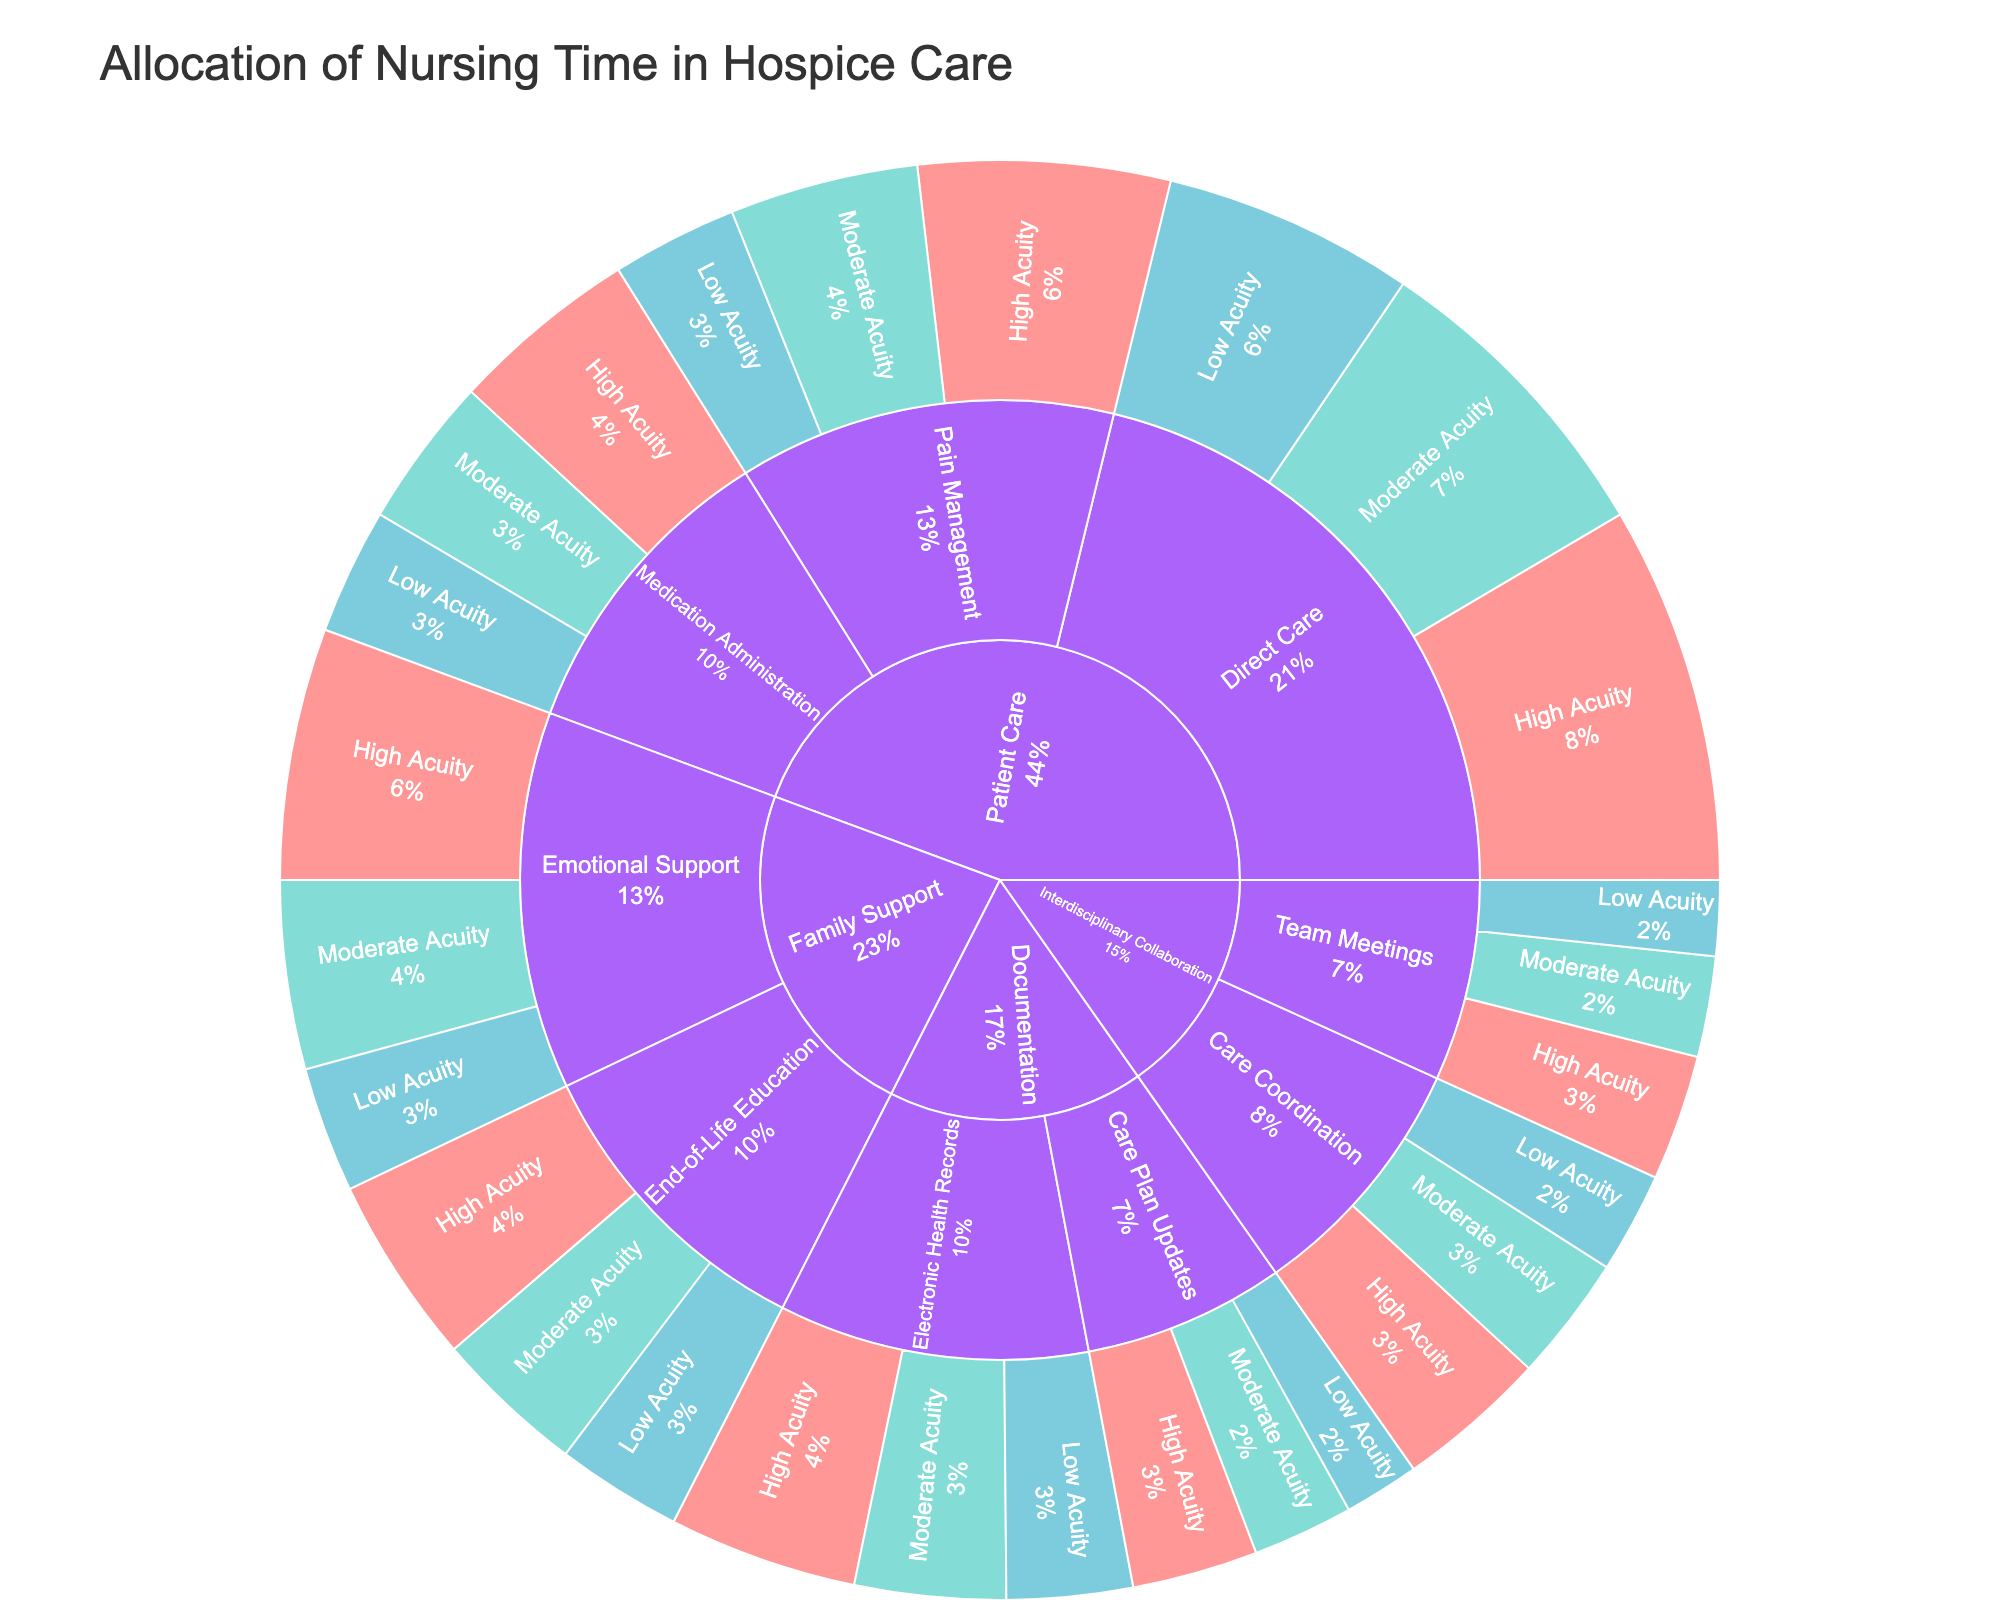What's the largest task category in terms of nursing time allocation? The largest task category can be determined by comparing the different main sections (Patient Care, Documentation, Family Support, Interdisciplinary Collaboration). Patient Care has the largest area, indicating it consumes the most time.
Answer: Patient Care How much time is spent on Direct Care across all acuity levels? Direct Care has time contributions from three acuity levels: High Acuity (30), Moderate Acuity (25), and Low Acuity (20). Adding these times gives 30 + 25 + 20 = 75 minutes.
Answer: 75 minutes Which acuity level consumes the most time in Medication Administration? By looking at the segments under Medication Administration, High Acuity has the largest segment compared to Moderate and Low Acuity.
Answer: High Acuity What is the total time spent on Documentation for Low Acuity patients? For Documentation, Low Acuity time is the sum of Electronic Health Records (10) and Care Plan Updates (6). Adding these gives 10 + 6 = 16 minutes.
Answer: 16 minutes How does time spent on Emotional Support compare across different acuity levels? Comparing the sizes of the Emotional Support segments, High Acuity (20 minutes) is larger than Moderate Acuity (15 minutes), which in turn is larger than Low Acuity (10 minutes).
Answer: High > Moderate > Low What's the total time allocated to Family Support for High Acuity patients? Family Support for High Acuity includes Emotional Support (20) and End-of-Life Education (15). Adding these gives 20 + 15 = 35 minutes.
Answer: 35 minutes Which overall category has the least amount of time allocated? By comparing the full sections: Patient Care, Documentation, Family Support, and Interdisciplinary Collaboration, Interdisciplinary Collaboration is the smallest, thus the least time allocated.
Answer: Interdisciplinary Collaboration How does the time spent on Care Coordination in Interdisciplinary Collaboration differ by acuity level? Care Coordination times are High Acuity (12), Moderate Acuity (10), and Low Acuity (8). The differences are: High > Moderate by 2 minutes, and Moderate > Low by 2 minutes.
Answer: High > Moderate > Low What percentage of the total nursing time is spent on Pain Management for High Acuity patients? Pain Management for High Acuity is 20 minutes. The total time across all categories and acuity levels is the sum of all times (255 minutes). The percentage is (20/255) * 100 ≈ 7.84%.
Answer: 7.84% Which task category has the highest time allocation for Low Acuity patients? By comparing Low Acuity times in each task category (Direct Care: 20, Medication Administration: 10, Pain Management: 10, Electronic Health Records: 10, Care Plan Updates: 6, Emotional Support: 10, End-of-Life Education: 10, Team Meetings: 6, Care Coordination: 8), Direct Care (20 minutes) is the highest.
Answer: Direct Care 